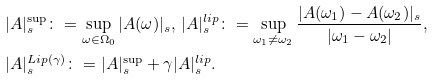Convert formula to latex. <formula><loc_0><loc_0><loc_500><loc_500>& | A | _ { s } ^ { \sup } \colon = \sup _ { \omega \in \Omega _ { 0 } } | A ( \omega ) | _ { s } , \, | A | _ { s } ^ { l i p } \colon = \sup _ { \omega _ { 1 } \neq \omega _ { 2 } } \frac { | A ( \omega _ { 1 } ) - A ( \omega _ { 2 } ) | _ { s } } { | \omega _ { 1 } - \omega _ { 2 } | } , \\ & | A | _ { s } ^ { L i p ( \gamma ) } \colon = | A | _ { s } ^ { \sup } + \gamma | A | _ { s } ^ { l i p } .</formula> 